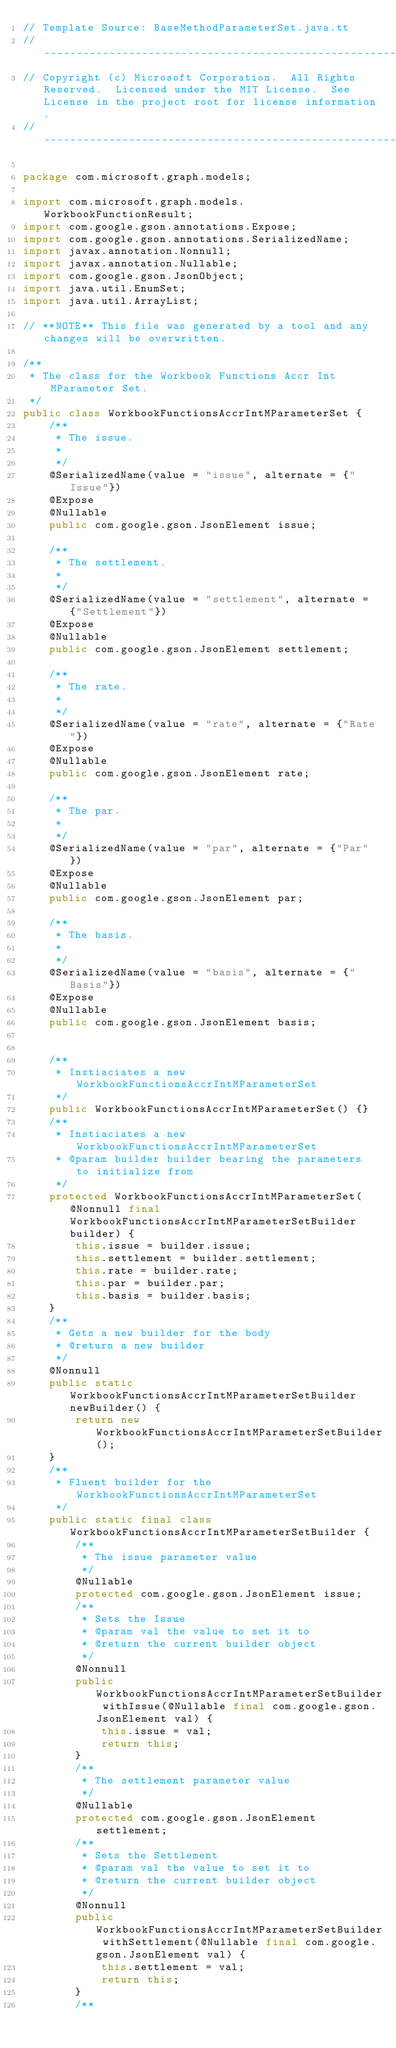<code> <loc_0><loc_0><loc_500><loc_500><_Java_>// Template Source: BaseMethodParameterSet.java.tt
// ------------------------------------------------------------------------------
// Copyright (c) Microsoft Corporation.  All Rights Reserved.  Licensed under the MIT License.  See License in the project root for license information.
// ------------------------------------------------------------------------------

package com.microsoft.graph.models;

import com.microsoft.graph.models.WorkbookFunctionResult;
import com.google.gson.annotations.Expose;
import com.google.gson.annotations.SerializedName;
import javax.annotation.Nonnull;
import javax.annotation.Nullable;
import com.google.gson.JsonObject;
import java.util.EnumSet;
import java.util.ArrayList;

// **NOTE** This file was generated by a tool and any changes will be overwritten.

/**
 * The class for the Workbook Functions Accr Int MParameter Set.
 */
public class WorkbookFunctionsAccrIntMParameterSet {
    /**
     * The issue.
     * 
     */
    @SerializedName(value = "issue", alternate = {"Issue"})
    @Expose
	@Nullable
    public com.google.gson.JsonElement issue;

    /**
     * The settlement.
     * 
     */
    @SerializedName(value = "settlement", alternate = {"Settlement"})
    @Expose
	@Nullable
    public com.google.gson.JsonElement settlement;

    /**
     * The rate.
     * 
     */
    @SerializedName(value = "rate", alternate = {"Rate"})
    @Expose
	@Nullable
    public com.google.gson.JsonElement rate;

    /**
     * The par.
     * 
     */
    @SerializedName(value = "par", alternate = {"Par"})
    @Expose
	@Nullable
    public com.google.gson.JsonElement par;

    /**
     * The basis.
     * 
     */
    @SerializedName(value = "basis", alternate = {"Basis"})
    @Expose
	@Nullable
    public com.google.gson.JsonElement basis;


    /**
     * Instiaciates a new WorkbookFunctionsAccrIntMParameterSet
     */
    public WorkbookFunctionsAccrIntMParameterSet() {}
    /**
     * Instiaciates a new WorkbookFunctionsAccrIntMParameterSet
     * @param builder builder bearing the parameters to initialize from
     */
    protected WorkbookFunctionsAccrIntMParameterSet(@Nonnull final WorkbookFunctionsAccrIntMParameterSetBuilder builder) {
        this.issue = builder.issue;
        this.settlement = builder.settlement;
        this.rate = builder.rate;
        this.par = builder.par;
        this.basis = builder.basis;
    }
    /**
     * Gets a new builder for the body
     * @return a new builder
     */
    @Nonnull
    public static WorkbookFunctionsAccrIntMParameterSetBuilder newBuilder() {
        return new WorkbookFunctionsAccrIntMParameterSetBuilder();
    }
    /**
     * Fluent builder for the WorkbookFunctionsAccrIntMParameterSet
     */
    public static final class WorkbookFunctionsAccrIntMParameterSetBuilder {
        /**
         * The issue parameter value
         */
        @Nullable
        protected com.google.gson.JsonElement issue;
        /**
         * Sets the Issue
         * @param val the value to set it to
         * @return the current builder object
         */
        @Nonnull
        public WorkbookFunctionsAccrIntMParameterSetBuilder withIssue(@Nullable final com.google.gson.JsonElement val) {
            this.issue = val;
            return this;
        }
        /**
         * The settlement parameter value
         */
        @Nullable
        protected com.google.gson.JsonElement settlement;
        /**
         * Sets the Settlement
         * @param val the value to set it to
         * @return the current builder object
         */
        @Nonnull
        public WorkbookFunctionsAccrIntMParameterSetBuilder withSettlement(@Nullable final com.google.gson.JsonElement val) {
            this.settlement = val;
            return this;
        }
        /**</code> 